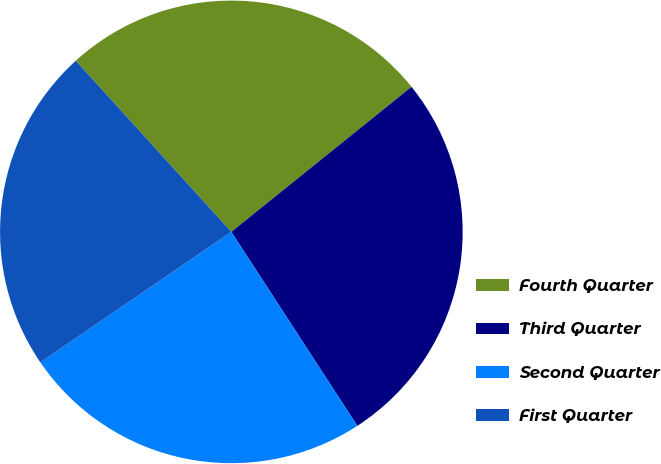Convert chart. <chart><loc_0><loc_0><loc_500><loc_500><pie_chart><fcel>Fourth Quarter<fcel>Third Quarter<fcel>Second Quarter<fcel>First Quarter<nl><fcel>25.95%<fcel>26.62%<fcel>24.63%<fcel>22.79%<nl></chart> 